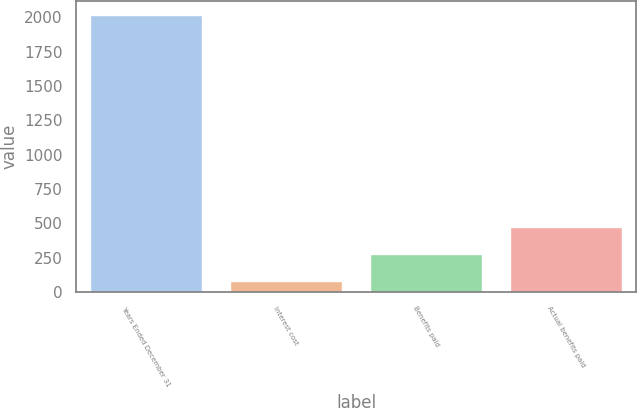Convert chart. <chart><loc_0><loc_0><loc_500><loc_500><bar_chart><fcel>Years Ended December 31<fcel>Interest cost<fcel>Benefits paid<fcel>Actual benefits paid<nl><fcel>2016<fcel>85<fcel>278.1<fcel>471.2<nl></chart> 